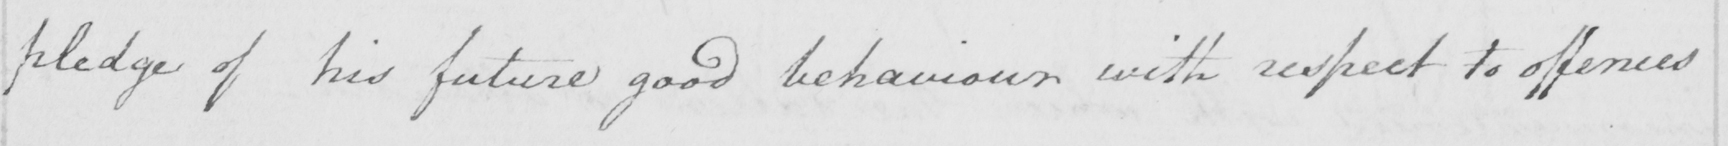Transcribe the text shown in this historical manuscript line. pledge of his future good behaviour with respect to offences 